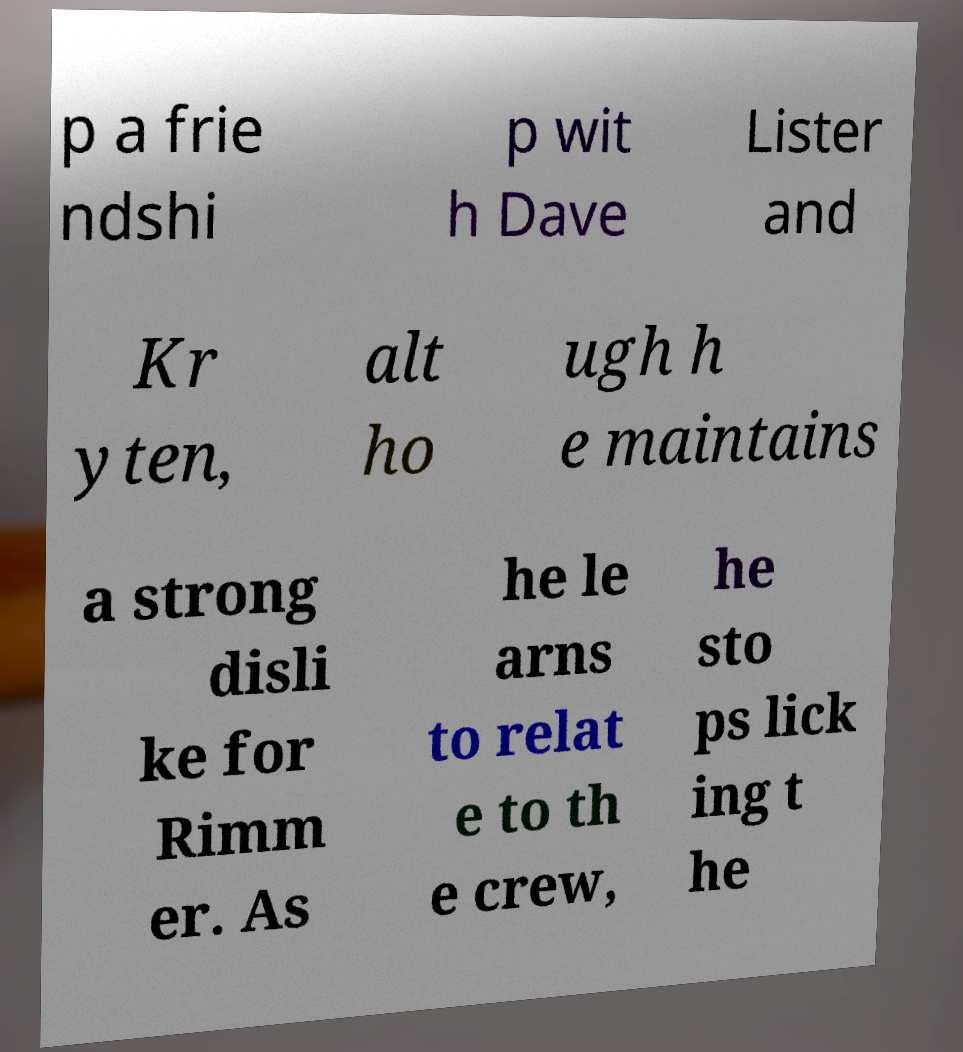Can you read and provide the text displayed in the image?This photo seems to have some interesting text. Can you extract and type it out for me? p a frie ndshi p wit h Dave Lister and Kr yten, alt ho ugh h e maintains a strong disli ke for Rimm er. As he le arns to relat e to th e crew, he sto ps lick ing t he 